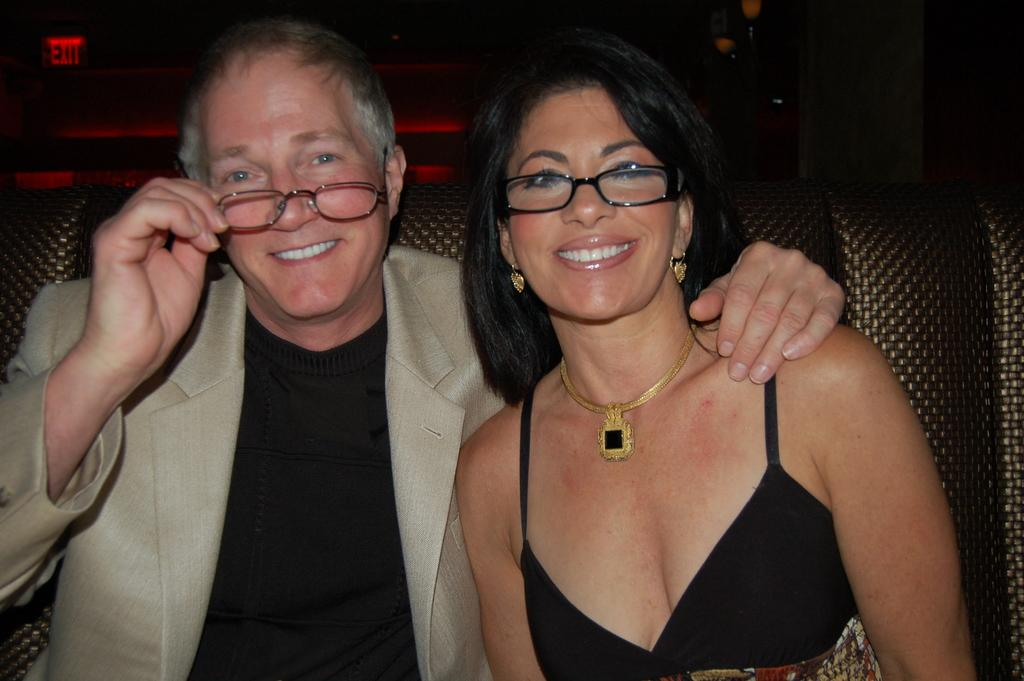How many people are in the image? There are two people in the image. What are the people wearing? The people are wearing goggles. What are the people doing in the image? The people are sitting on a sofa. What can be seen in the background of the image? There is some lighting in the background of the image. What type of wall is visible in the image? There is no wall visible in the image; it only shows two people sitting on a sofa and wearing goggles. 